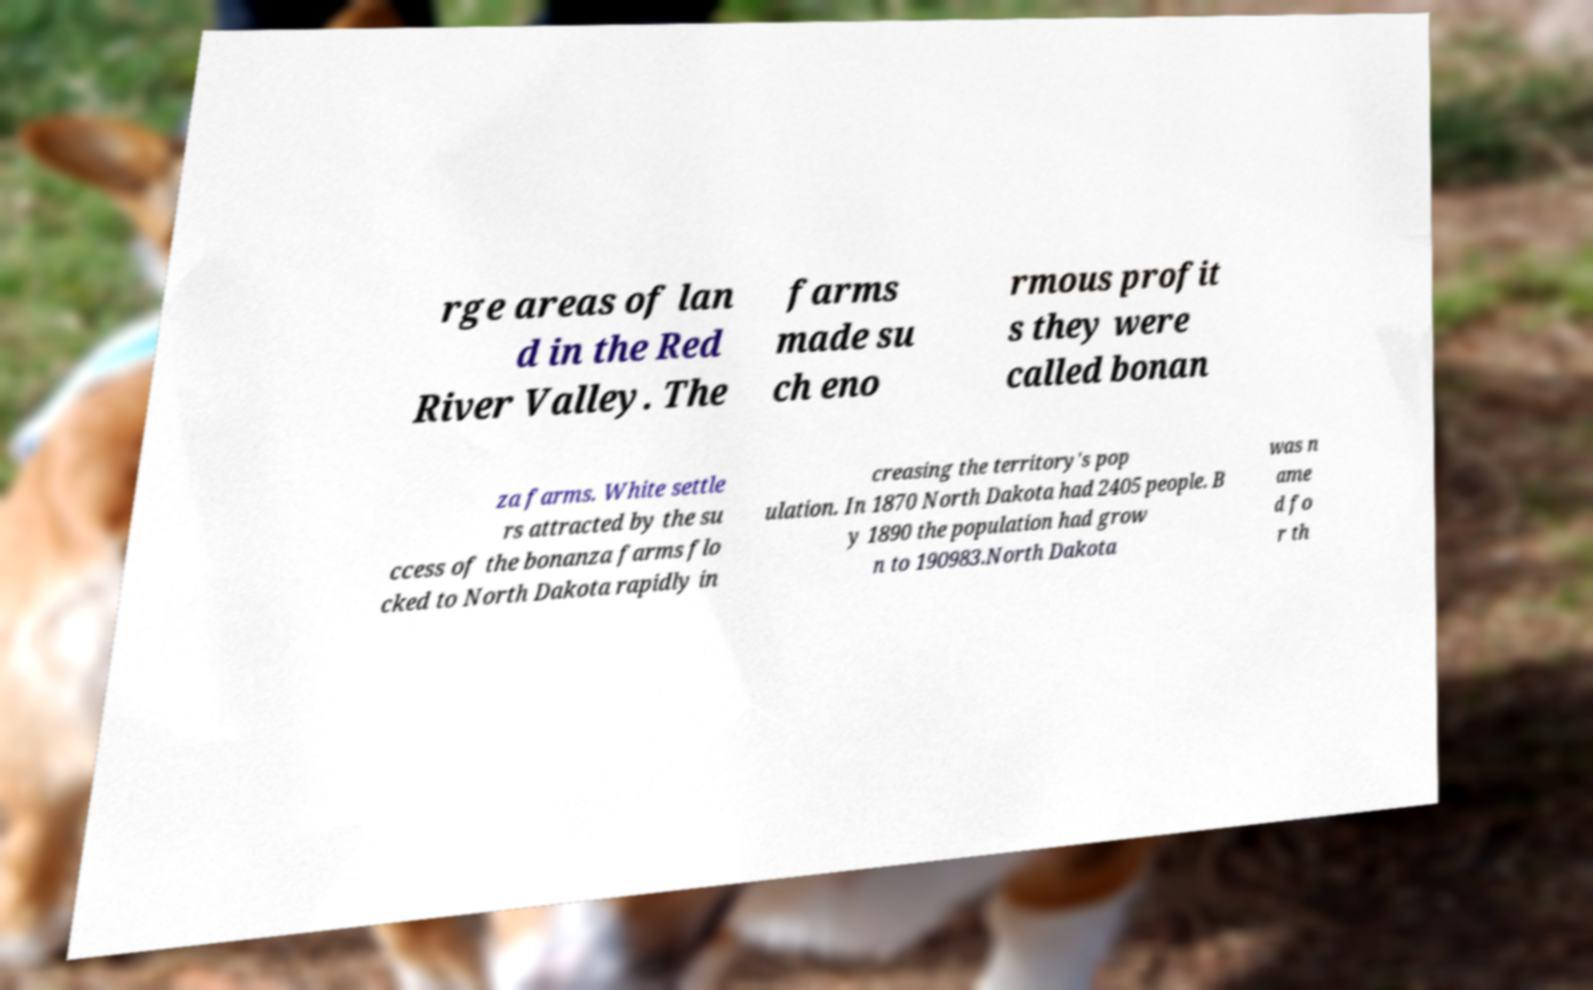Can you read and provide the text displayed in the image?This photo seems to have some interesting text. Can you extract and type it out for me? rge areas of lan d in the Red River Valley. The farms made su ch eno rmous profit s they were called bonan za farms. White settle rs attracted by the su ccess of the bonanza farms flo cked to North Dakota rapidly in creasing the territory's pop ulation. In 1870 North Dakota had 2405 people. B y 1890 the population had grow n to 190983.North Dakota was n ame d fo r th 